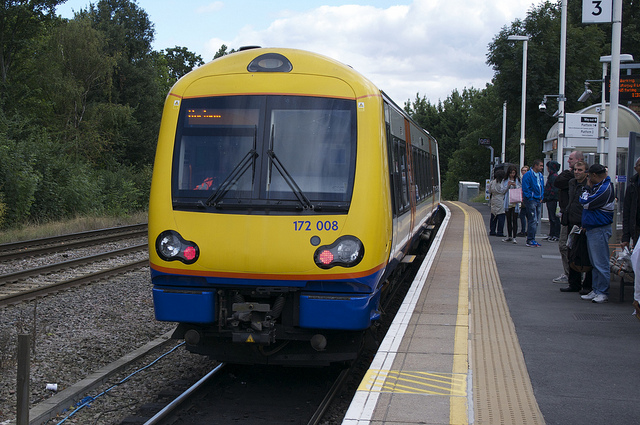Please transcribe the text in this image. 172 008 3 